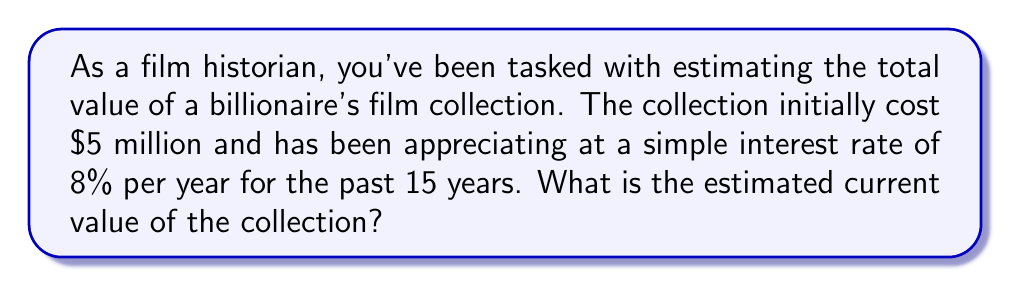What is the answer to this math problem? Let's break this down step-by-step using the simple interest formula:

1) The simple interest formula is:
   $A = P(1 + rt)$
   Where:
   $A$ = Final amount
   $P$ = Principal (initial investment)
   $r$ = Annual interest rate (in decimal form)
   $t$ = Time in years

2) We know:
   $P = \$5,000,000$ (initial cost)
   $r = 0.08$ (8% converted to decimal)
   $t = 15$ years

3) Let's plug these values into the formula:
   $A = 5,000,000(1 + 0.08 \times 15)$

4) Simplify the parentheses:
   $A = 5,000,000(1 + 1.2)$
   $A = 5,000,000(2.2)$

5) Multiply:
   $A = 11,000,000$

Therefore, the estimated current value of the collection is $11 million.
Answer: $11 million 